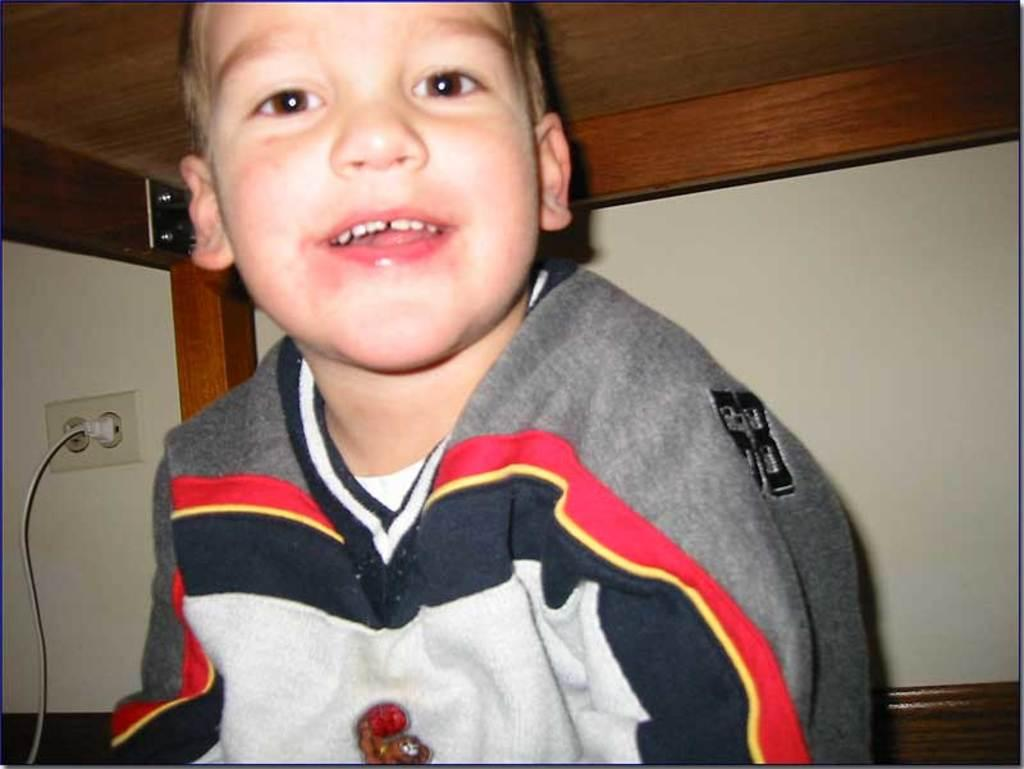Who is the main subject in the image? There is a boy in the center of the image. What is the boy's expression in the image? The boy is smiling in the image. What can be seen in the background of the image? There is a wall in the background of the image. What is located at the top of the image? There is a table at the top of the image. What type of pin is the boy wearing on his skin in the image? There is no pin or reference to the boy's skin visible in the image. What tax rate is applied to the items on the table in the image? There is no information about tax rates or items on the table in the image. 